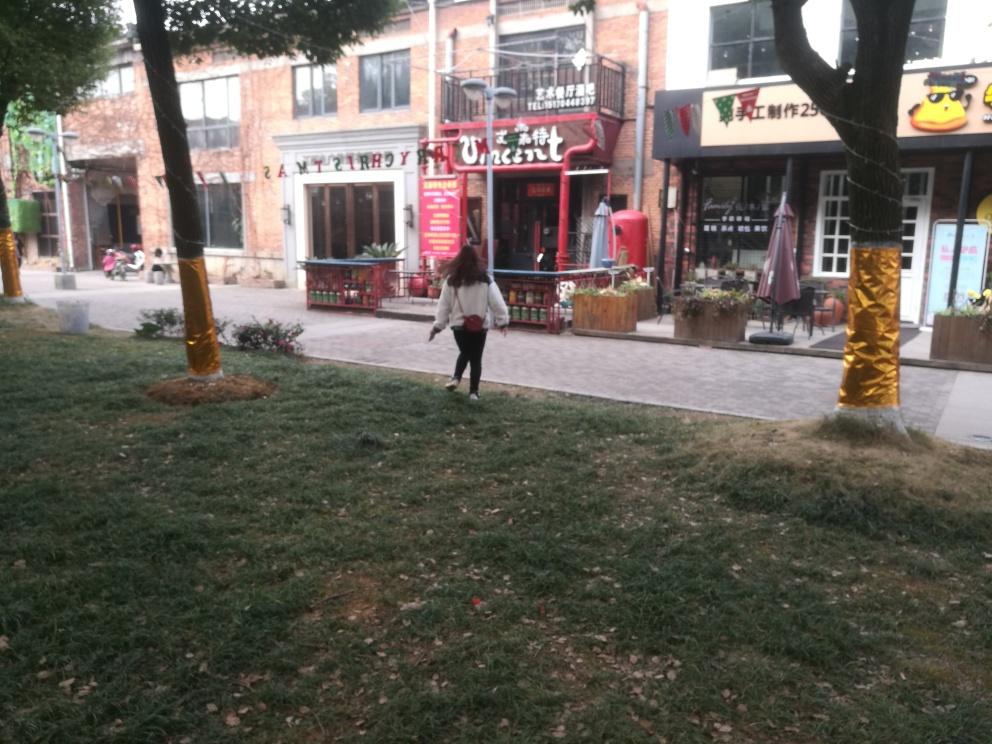What kind of establishments are visible in the image? The image showcases several commercial establishments. On the left, there's a restaurant with outdoor seating and red signage. On the right, there appears to be a shop with a green and white signboard and various items displayed in the window. 